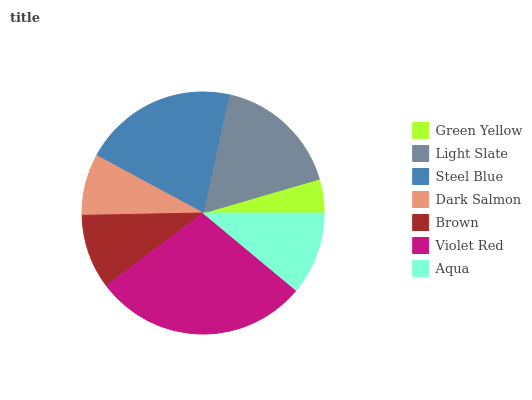Is Green Yellow the minimum?
Answer yes or no. Yes. Is Violet Red the maximum?
Answer yes or no. Yes. Is Light Slate the minimum?
Answer yes or no. No. Is Light Slate the maximum?
Answer yes or no. No. Is Light Slate greater than Green Yellow?
Answer yes or no. Yes. Is Green Yellow less than Light Slate?
Answer yes or no. Yes. Is Green Yellow greater than Light Slate?
Answer yes or no. No. Is Light Slate less than Green Yellow?
Answer yes or no. No. Is Aqua the high median?
Answer yes or no. Yes. Is Aqua the low median?
Answer yes or no. Yes. Is Violet Red the high median?
Answer yes or no. No. Is Light Slate the low median?
Answer yes or no. No. 